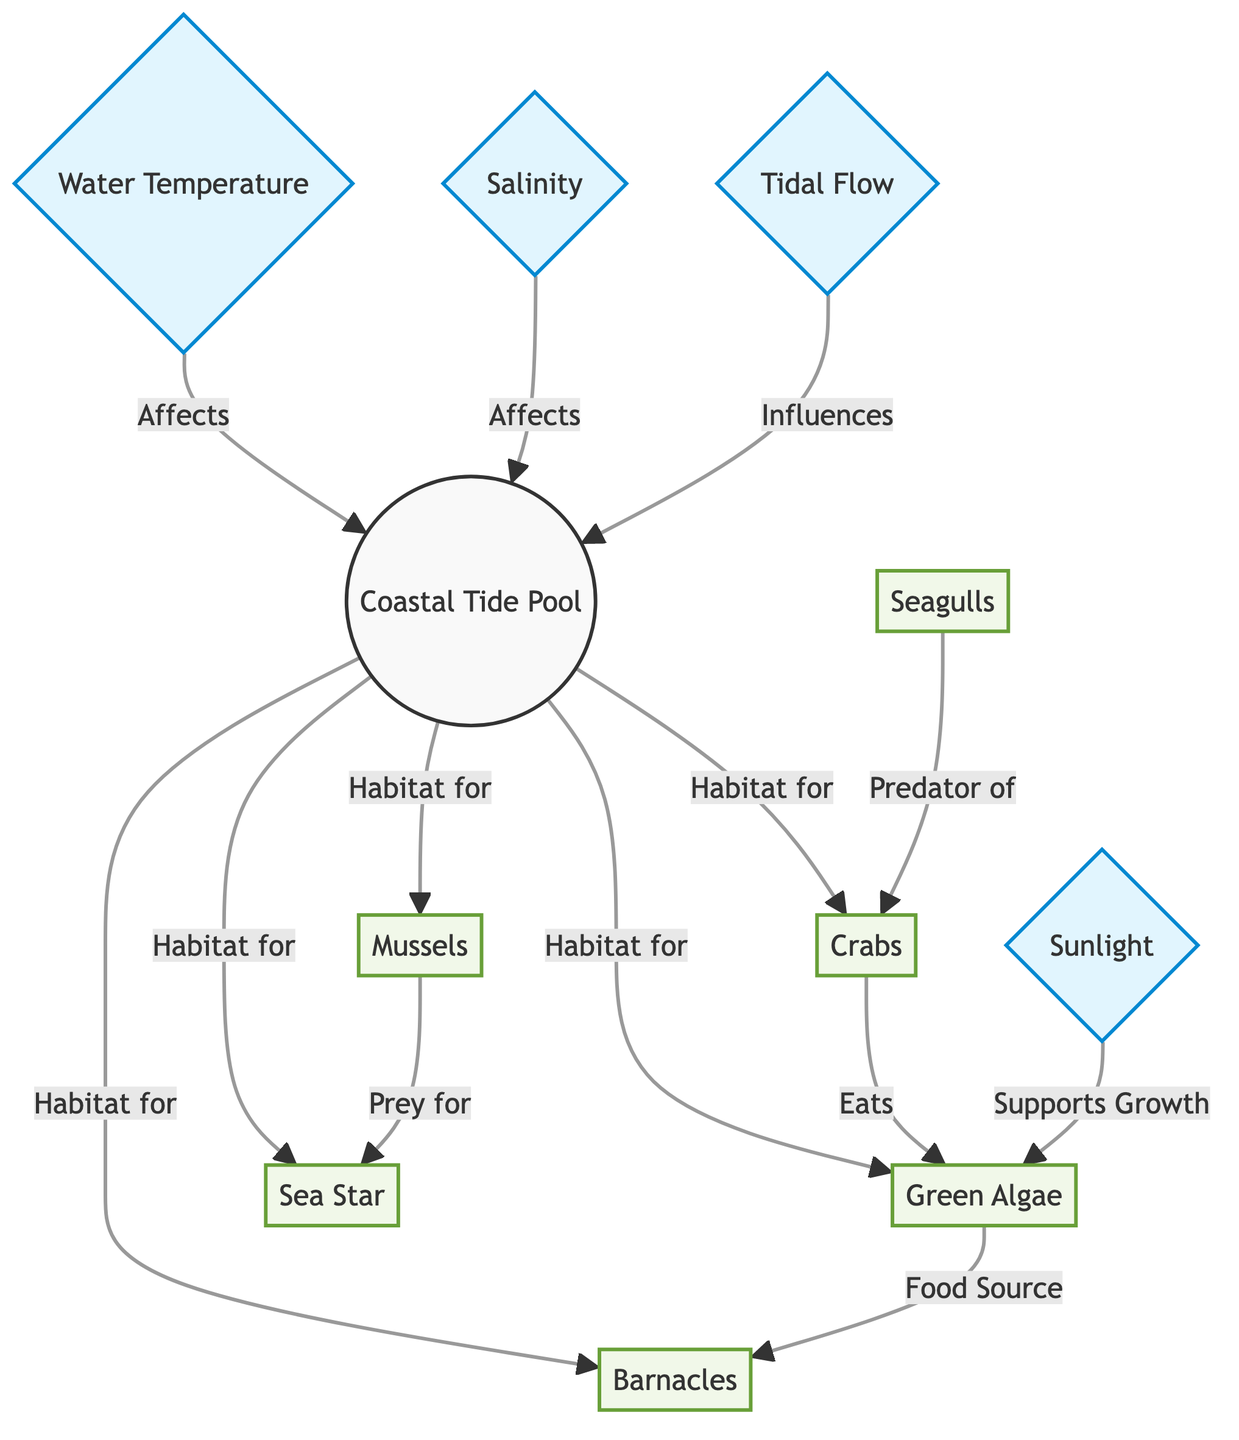What are the species that inhabit the coastal tide pool? The diagram shows six species that inhabit the coastal tide pool: Green Algae, Barnacles, Sea Star, Mussels, Crabs, and Seagulls. Each of these species is directly connected to the "Coastal Tide Pool" node.
Answer: Green Algae, Barnacles, Sea Star, Mussels, Crabs, Seagulls Which species is a predator of crabs? According to the diagram, Seagulls are shown as a predator of Crabs. The relationship is specified, indicating that Crabs are prey to Seagulls.
Answer: Seagulls How many species interactions involve Green Algae? The diagram identifies two interactions involving Green Algae: it serves as a food source for Barnacles and is eaten by Crabs. Therefore, the count of interactions is two.
Answer: 2 What environmental factor supports the growth of algae? The diagram illustrates that Sunlight supports the growth of Algae. This indicates a direct relationship where the availability of sunlight is crucial for the algae's growth in the tide pool.
Answer: Sunlight Which environmental factor influences the tide pool? The diagram shows three environmental factors that influence the tide pool: Water Temperature, Salinity, and Tidal Flow. All three factors are connected to the "Coastal Tide Pool."
Answer: Water Temperature, Salinity, Tidal Flow What is the relationship between mussels and sea stars? The diagram indicates that Mussels are prey for Sea Stars. This relationship highlights the predator-prey dynamic between these two species within the coastal tide pool ecosystem.
Answer: Prey for How does salinity affect the tide pool? The diagram explicitly states that Salinity affects the Tide Pool. This suggests that variations in salinity levels can influence the overall conditions within the tide pool habitat.
Answer: Affects What is the total number of species mentioned in the diagram? There are six species listed in the diagram (Green Algae, Barnacles, Sea Star, Mussels, Crabs, and Seagulls). By counting these species, we find the total number.
Answer: 6 